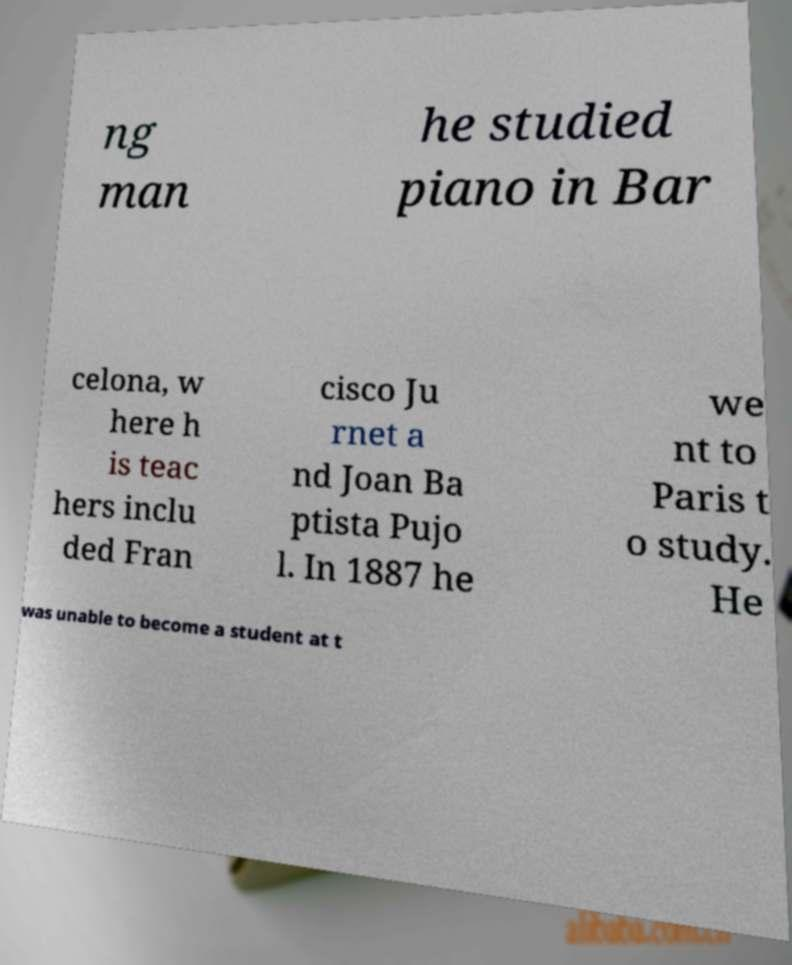Could you extract and type out the text from this image? ng man he studied piano in Bar celona, w here h is teac hers inclu ded Fran cisco Ju rnet a nd Joan Ba ptista Pujo l. In 1887 he we nt to Paris t o study. He was unable to become a student at t 